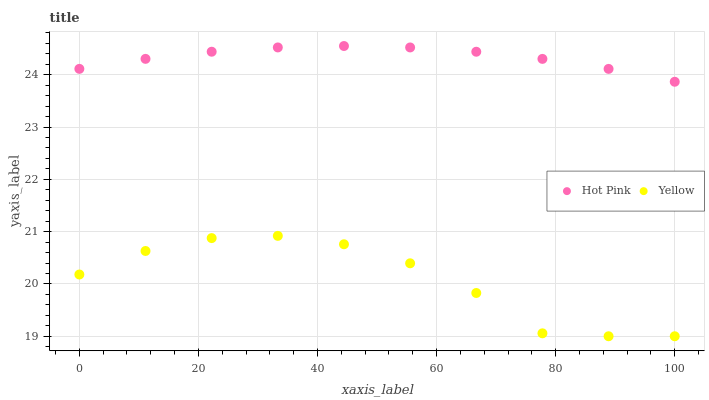Does Yellow have the minimum area under the curve?
Answer yes or no. Yes. Does Hot Pink have the maximum area under the curve?
Answer yes or no. Yes. Does Yellow have the maximum area under the curve?
Answer yes or no. No. Is Hot Pink the smoothest?
Answer yes or no. Yes. Is Yellow the roughest?
Answer yes or no. Yes. Is Yellow the smoothest?
Answer yes or no. No. Does Yellow have the lowest value?
Answer yes or no. Yes. Does Hot Pink have the highest value?
Answer yes or no. Yes. Does Yellow have the highest value?
Answer yes or no. No. Is Yellow less than Hot Pink?
Answer yes or no. Yes. Is Hot Pink greater than Yellow?
Answer yes or no. Yes. Does Yellow intersect Hot Pink?
Answer yes or no. No. 